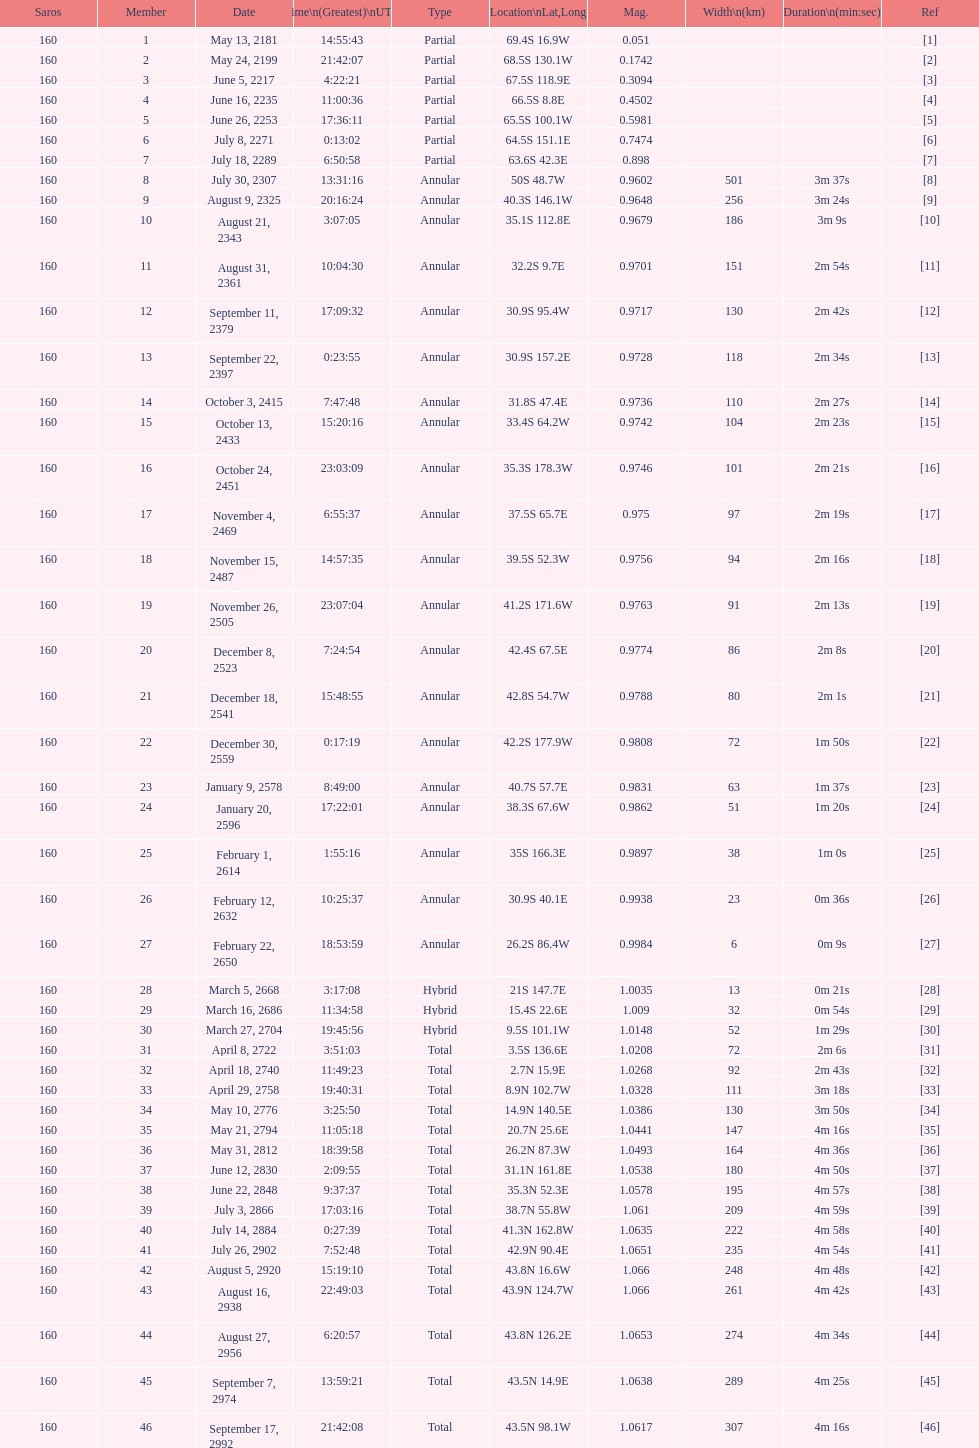00? March 5, 2668. 